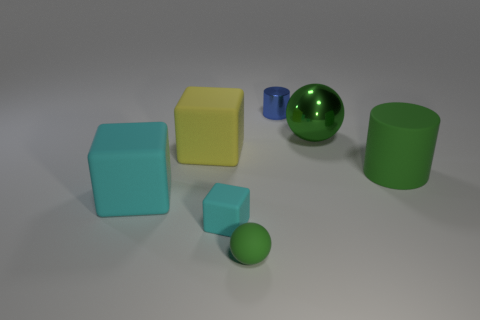What color is the tiny rubber object that is on the left side of the green rubber sphere?
Provide a succinct answer. Cyan. Are there any large yellow objects of the same shape as the tiny cyan object?
Give a very brief answer. Yes. What material is the small blue cylinder?
Offer a very short reply. Metal. What size is the matte object that is behind the small green sphere and on the right side of the tiny cyan object?
Make the answer very short. Large. What material is the big object that is the same color as the large rubber cylinder?
Offer a terse response. Metal. How many blue metallic cylinders are there?
Provide a succinct answer. 1. Is the number of tiny green objects less than the number of large rubber blocks?
Keep it short and to the point. Yes. What material is the ball that is the same size as the yellow cube?
Keep it short and to the point. Metal. How many things are green spheres or green metal objects?
Provide a short and direct response. 2. How many tiny objects are to the left of the small rubber ball and on the right side of the small green rubber sphere?
Give a very brief answer. 0. 